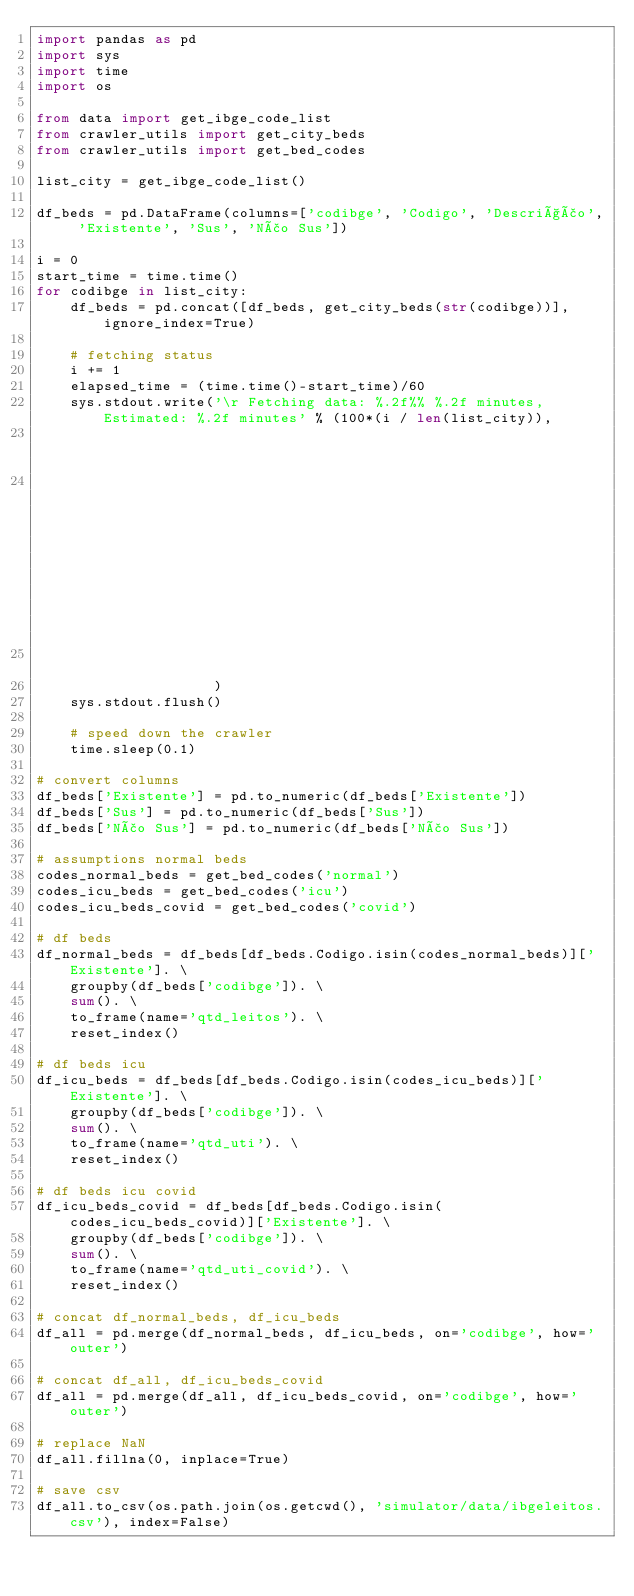Convert code to text. <code><loc_0><loc_0><loc_500><loc_500><_Python_>import pandas as pd
import sys
import time
import os

from data import get_ibge_code_list
from crawler_utils import get_city_beds
from crawler_utils import get_bed_codes

list_city = get_ibge_code_list()

df_beds = pd.DataFrame(columns=['codibge', 'Codigo', 'Descrição', 'Existente', 'Sus', 'Não Sus'])

i = 0
start_time = time.time()
for codibge in list_city:
    df_beds = pd.concat([df_beds, get_city_beds(str(codibge))], ignore_index=True)

    # fetching status
    i += 1
    elapsed_time = (time.time()-start_time)/60
    sys.stdout.write('\r Fetching data: %.2f%% %.2f minutes, Estimated: %.2f minutes' % (100*(i / len(list_city)),
                                                                                         elapsed_time,
                                                                                         (elapsed_time/i)*len(list_city)
                                                                                         )
                     )
    sys.stdout.flush()

    # speed down the crawler
    time.sleep(0.1)

# convert columns
df_beds['Existente'] = pd.to_numeric(df_beds['Existente'])
df_beds['Sus'] = pd.to_numeric(df_beds['Sus'])
df_beds['Não Sus'] = pd.to_numeric(df_beds['Não Sus'])

# assumptions normal beds
codes_normal_beds = get_bed_codes('normal')
codes_icu_beds = get_bed_codes('icu')
codes_icu_beds_covid = get_bed_codes('covid')

# df beds
df_normal_beds = df_beds[df_beds.Codigo.isin(codes_normal_beds)]['Existente']. \
    groupby(df_beds['codibge']). \
    sum(). \
    to_frame(name='qtd_leitos'). \
    reset_index()

# df beds icu
df_icu_beds = df_beds[df_beds.Codigo.isin(codes_icu_beds)]['Existente']. \
    groupby(df_beds['codibge']). \
    sum(). \
    to_frame(name='qtd_uti'). \
    reset_index()

# df beds icu covid
df_icu_beds_covid = df_beds[df_beds.Codigo.isin(codes_icu_beds_covid)]['Existente']. \
    groupby(df_beds['codibge']). \
    sum(). \
    to_frame(name='qtd_uti_covid'). \
    reset_index()

# concat df_normal_beds, df_icu_beds
df_all = pd.merge(df_normal_beds, df_icu_beds, on='codibge', how='outer')

# concat df_all, df_icu_beds_covid
df_all = pd.merge(df_all, df_icu_beds_covid, on='codibge', how='outer')

# replace NaN
df_all.fillna(0, inplace=True)

# save csv
df_all.to_csv(os.path.join(os.getcwd(), 'simulator/data/ibgeleitos.csv'), index=False)
</code> 